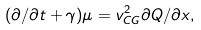Convert formula to latex. <formula><loc_0><loc_0><loc_500><loc_500>( \partial / \partial t + \gamma ) \mu = v _ { C G } ^ { 2 } \partial Q / \partial x ,</formula> 